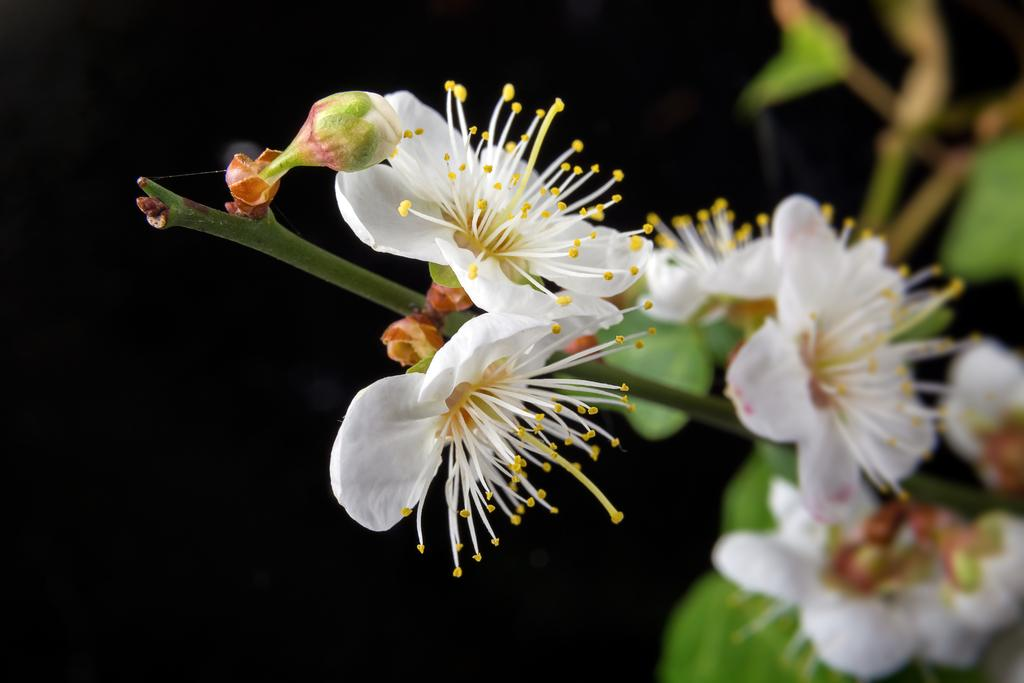What type of plants can be seen in the image? There are flowers and green leaves in the image. What color is the background of the image? The background of the image is dark. What process is being used to crush the flowers in the image? There is no process being used to crush the flowers in the image; they are not being crushed. In which bedroom can the flowers be seen in the image? The image does not show a bedroom, so it cannot be determined where the flowers are located in relation to a bedroom. 